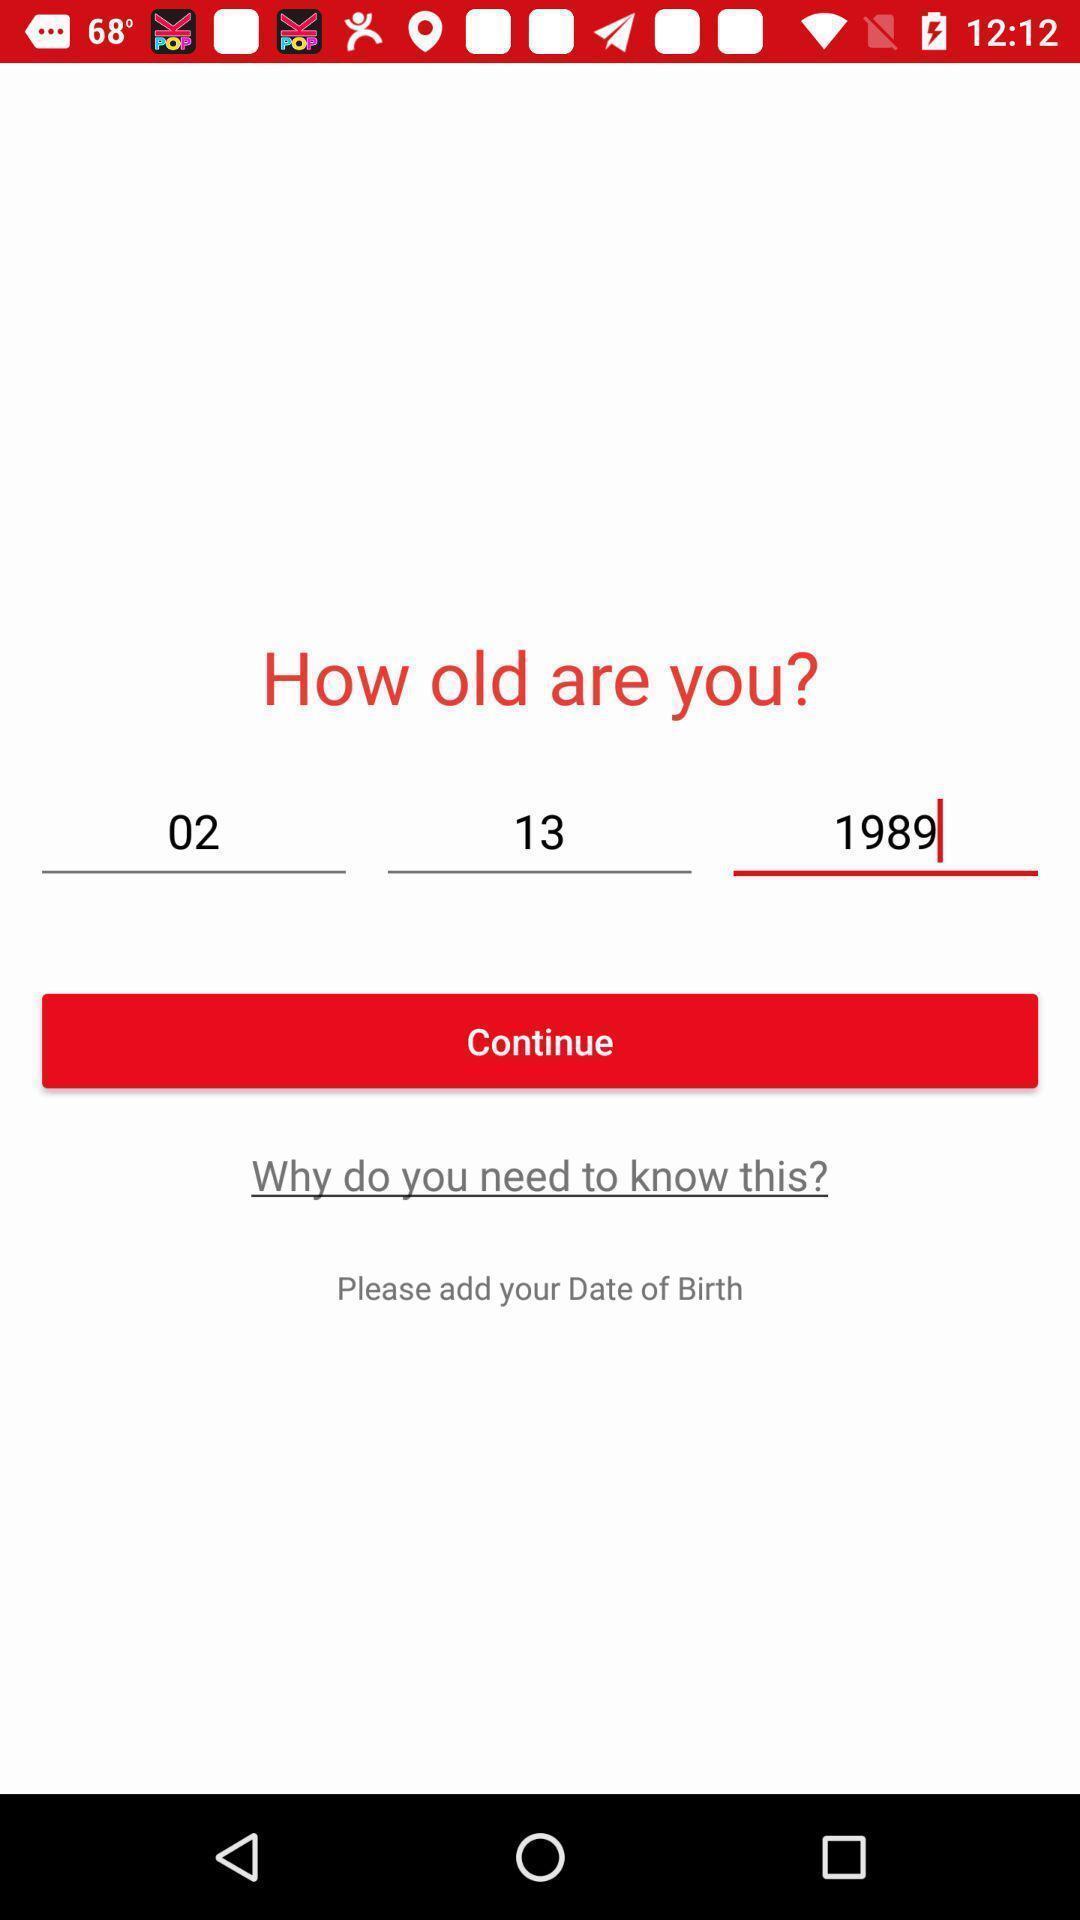Explain what's happening in this screen capture. Screen showing options to enter date of birth. 